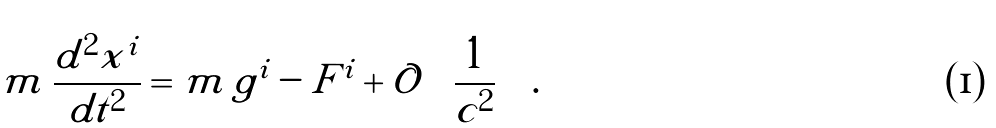Convert formula to latex. <formula><loc_0><loc_0><loc_500><loc_500>m \, \frac { d ^ { 2 } x ^ { i } } { d t ^ { 2 } } = m \, g ^ { i } - F ^ { i } + \mathcal { O } \left ( \frac { 1 } { c ^ { 2 } } \right ) \, .</formula> 